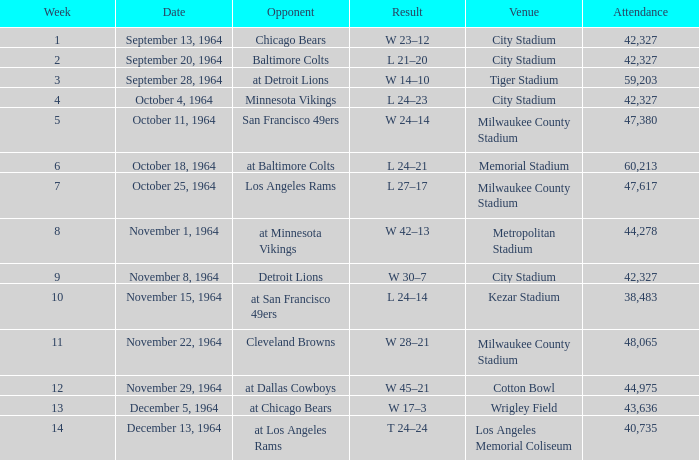At what site did the game that concluded with a 24-14 score take place? Kezar Stadium. 